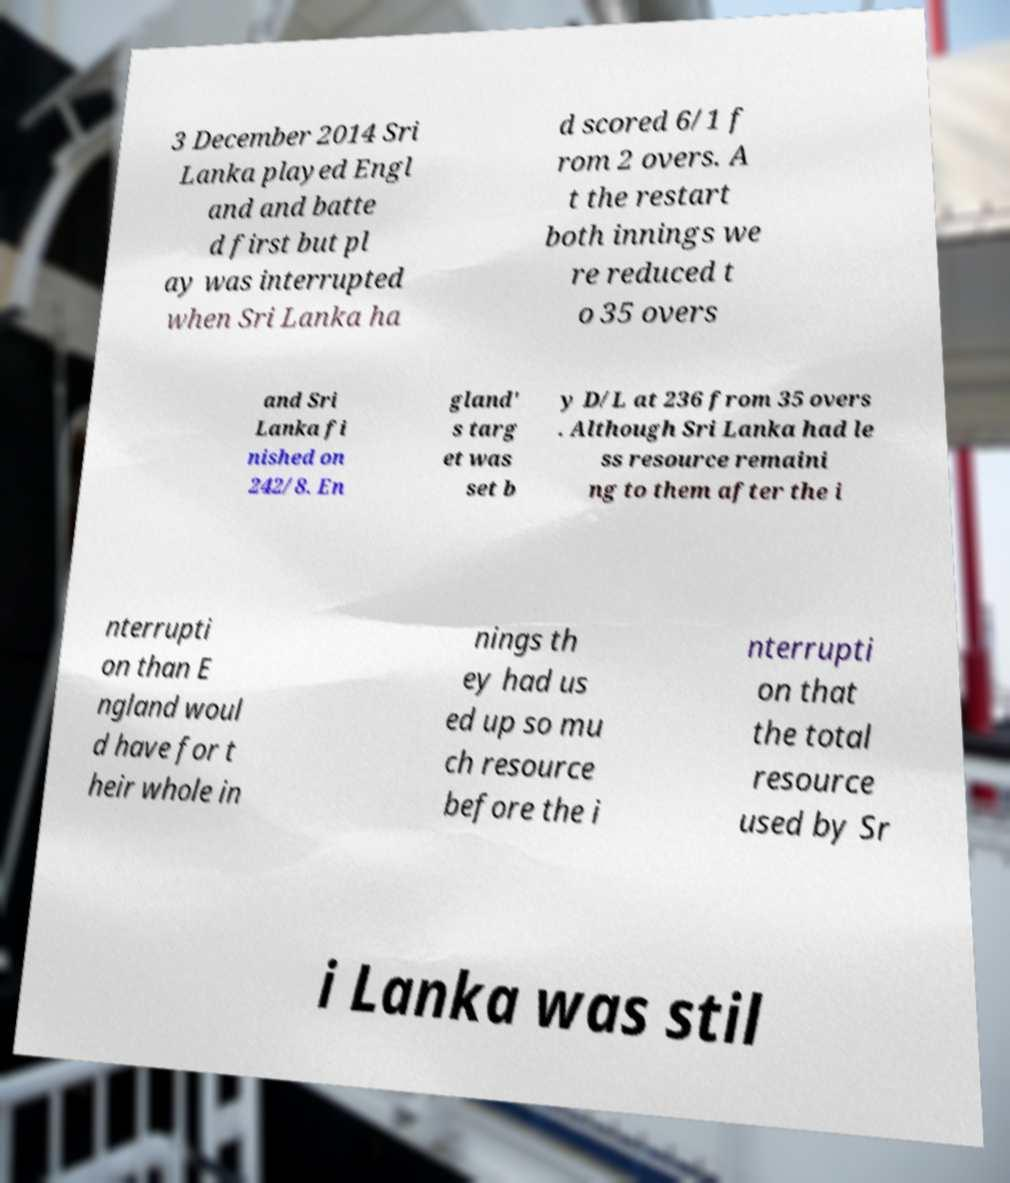I need the written content from this picture converted into text. Can you do that? 3 December 2014 Sri Lanka played Engl and and batte d first but pl ay was interrupted when Sri Lanka ha d scored 6/1 f rom 2 overs. A t the restart both innings we re reduced t o 35 overs and Sri Lanka fi nished on 242/8. En gland' s targ et was set b y D/L at 236 from 35 overs . Although Sri Lanka had le ss resource remaini ng to them after the i nterrupti on than E ngland woul d have for t heir whole in nings th ey had us ed up so mu ch resource before the i nterrupti on that the total resource used by Sr i Lanka was stil 